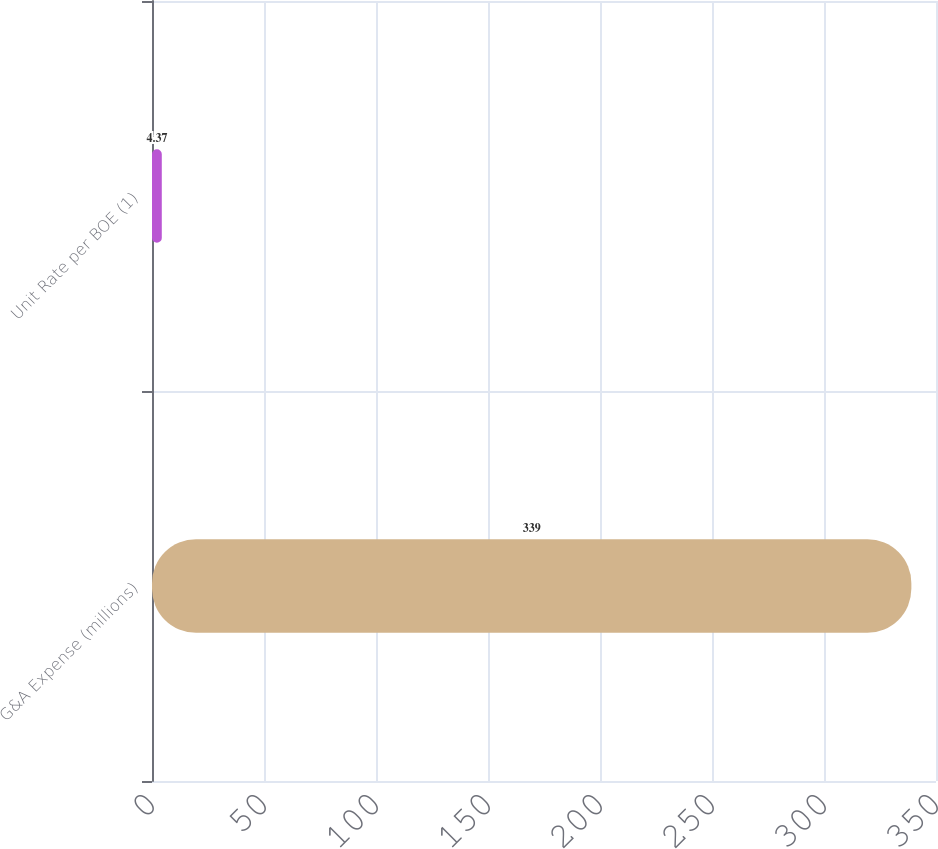Convert chart to OTSL. <chart><loc_0><loc_0><loc_500><loc_500><bar_chart><fcel>G&A Expense (millions)<fcel>Unit Rate per BOE (1)<nl><fcel>339<fcel>4.37<nl></chart> 